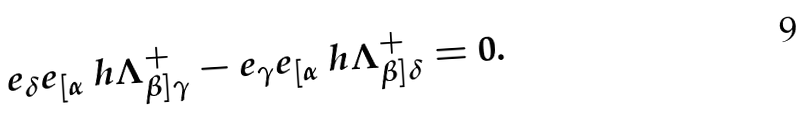Convert formula to latex. <formula><loc_0><loc_0><loc_500><loc_500>e _ { \delta } e _ { [ \alpha } \ h { \Lambda } ^ { + } _ { \beta ] \gamma } - e _ { \gamma } e _ { [ \alpha } \ h { \Lambda } ^ { + } _ { \beta ] \delta } = 0 .</formula> 